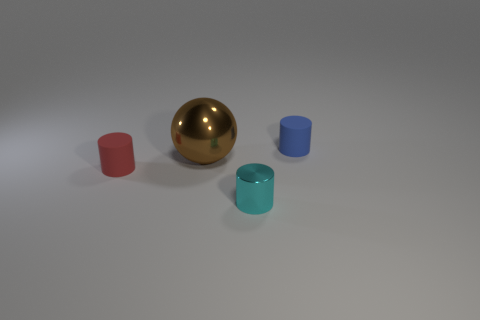Subtract all blue cylinders. Subtract all purple spheres. How many cylinders are left? 2 Add 4 red rubber cylinders. How many objects exist? 8 Subtract all spheres. How many objects are left? 3 Add 1 tiny matte objects. How many tiny matte objects are left? 3 Add 4 tiny metallic objects. How many tiny metallic objects exist? 5 Subtract 0 yellow blocks. How many objects are left? 4 Subtract all tiny purple cubes. Subtract all big metallic spheres. How many objects are left? 3 